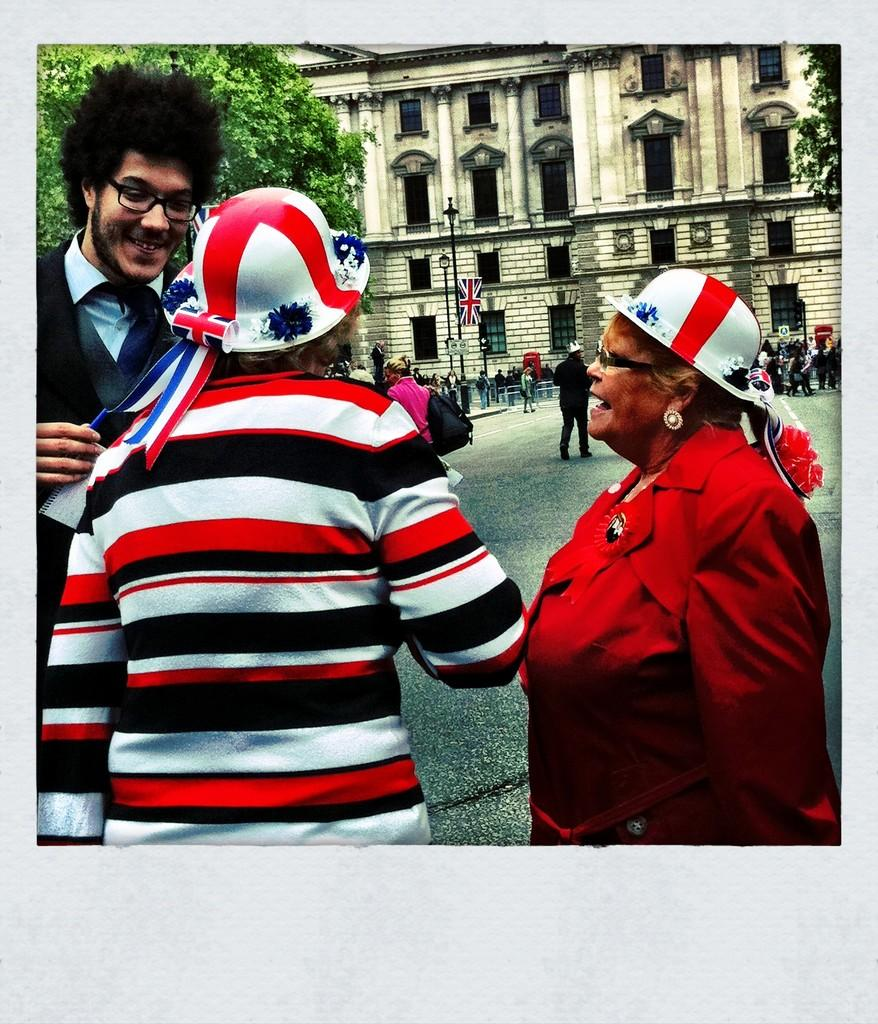How many people are standing on the road in the image? There are three persons standing on the road in the image. What can be seen in the background of the image? In the background of the image, there is a building, trees, light poles, a flag, and people. Can you describe the road in the image? The road is where the three persons are standing, but there is no specific information about its shape or condition. What type of cherries are being used to decorate the flag in the image? There are no cherries present in the image, and the flag does not appear to be decorated with any fruits. 